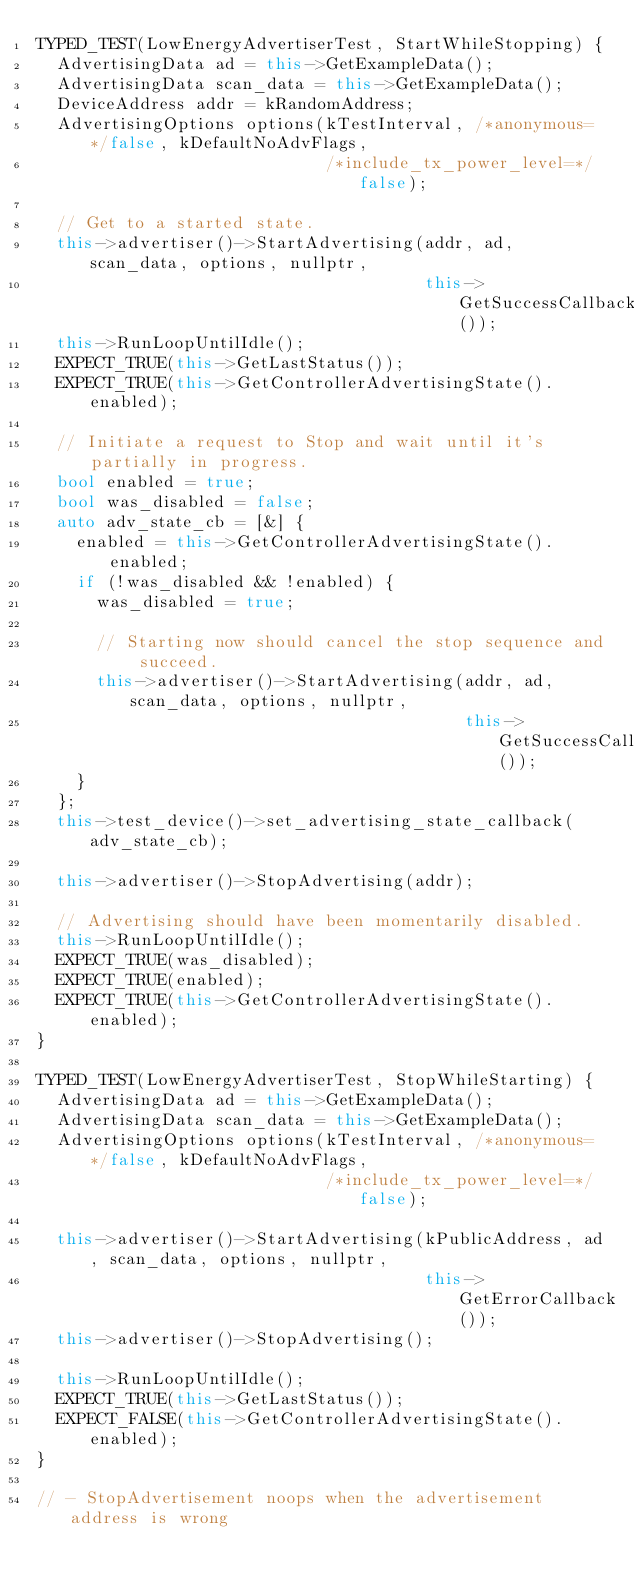Convert code to text. <code><loc_0><loc_0><loc_500><loc_500><_C++_>TYPED_TEST(LowEnergyAdvertiserTest, StartWhileStopping) {
  AdvertisingData ad = this->GetExampleData();
  AdvertisingData scan_data = this->GetExampleData();
  DeviceAddress addr = kRandomAddress;
  AdvertisingOptions options(kTestInterval, /*anonymous=*/false, kDefaultNoAdvFlags,
                             /*include_tx_power_level=*/false);

  // Get to a started state.
  this->advertiser()->StartAdvertising(addr, ad, scan_data, options, nullptr,
                                       this->GetSuccessCallback());
  this->RunLoopUntilIdle();
  EXPECT_TRUE(this->GetLastStatus());
  EXPECT_TRUE(this->GetControllerAdvertisingState().enabled);

  // Initiate a request to Stop and wait until it's partially in progress.
  bool enabled = true;
  bool was_disabled = false;
  auto adv_state_cb = [&] {
    enabled = this->GetControllerAdvertisingState().enabled;
    if (!was_disabled && !enabled) {
      was_disabled = true;

      // Starting now should cancel the stop sequence and succeed.
      this->advertiser()->StartAdvertising(addr, ad, scan_data, options, nullptr,
                                           this->GetSuccessCallback());
    }
  };
  this->test_device()->set_advertising_state_callback(adv_state_cb);

  this->advertiser()->StopAdvertising(addr);

  // Advertising should have been momentarily disabled.
  this->RunLoopUntilIdle();
  EXPECT_TRUE(was_disabled);
  EXPECT_TRUE(enabled);
  EXPECT_TRUE(this->GetControllerAdvertisingState().enabled);
}

TYPED_TEST(LowEnergyAdvertiserTest, StopWhileStarting) {
  AdvertisingData ad = this->GetExampleData();
  AdvertisingData scan_data = this->GetExampleData();
  AdvertisingOptions options(kTestInterval, /*anonymous=*/false, kDefaultNoAdvFlags,
                             /*include_tx_power_level=*/false);

  this->advertiser()->StartAdvertising(kPublicAddress, ad, scan_data, options, nullptr,
                                       this->GetErrorCallback());
  this->advertiser()->StopAdvertising();

  this->RunLoopUntilIdle();
  EXPECT_TRUE(this->GetLastStatus());
  EXPECT_FALSE(this->GetControllerAdvertisingState().enabled);
}

// - StopAdvertisement noops when the advertisement address is wrong</code> 